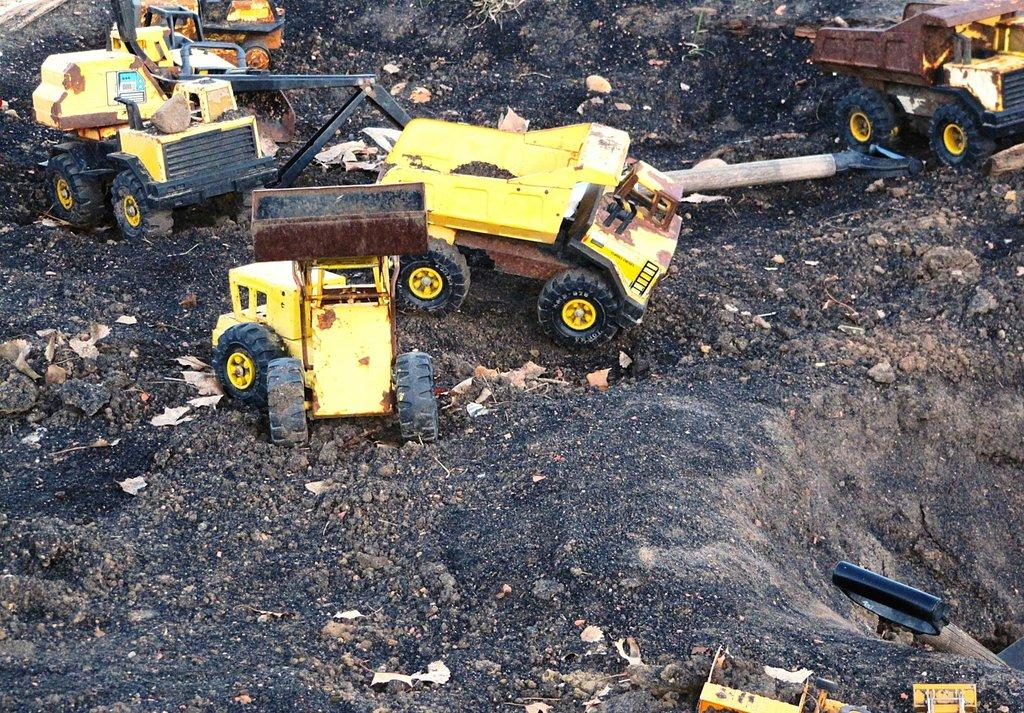What type of objects are on the ground in the image? There is a group of toy vehicles on the ground. What other items can be seen in the image? There are tools present in the image. What is the aftermath of the toy vehicle race in the image? There is no toy vehicle race depicted in the image, so there is no aftermath to discuss. 